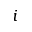<formula> <loc_0><loc_0><loc_500><loc_500>i</formula> 